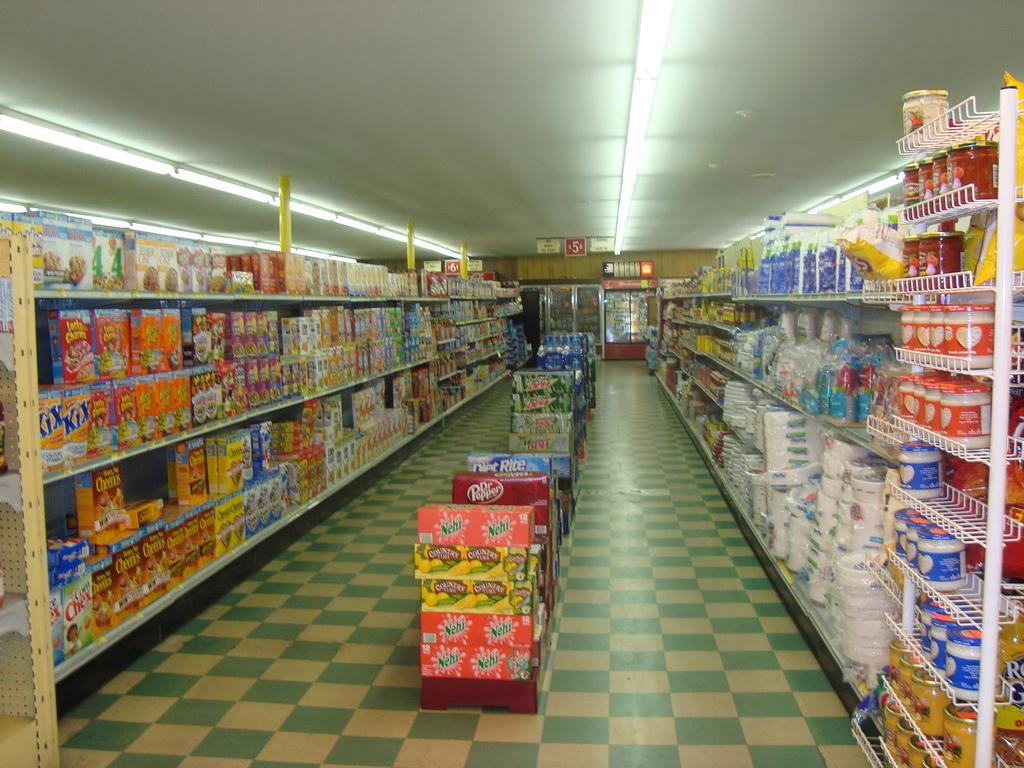<image>
Describe the image concisely. Dr Pepper, Mountain Dew and bottled water are among some of the products at this store. 